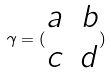<formula> <loc_0><loc_0><loc_500><loc_500>\gamma = ( \begin{matrix} a & b \\ c & d \end{matrix} )</formula> 